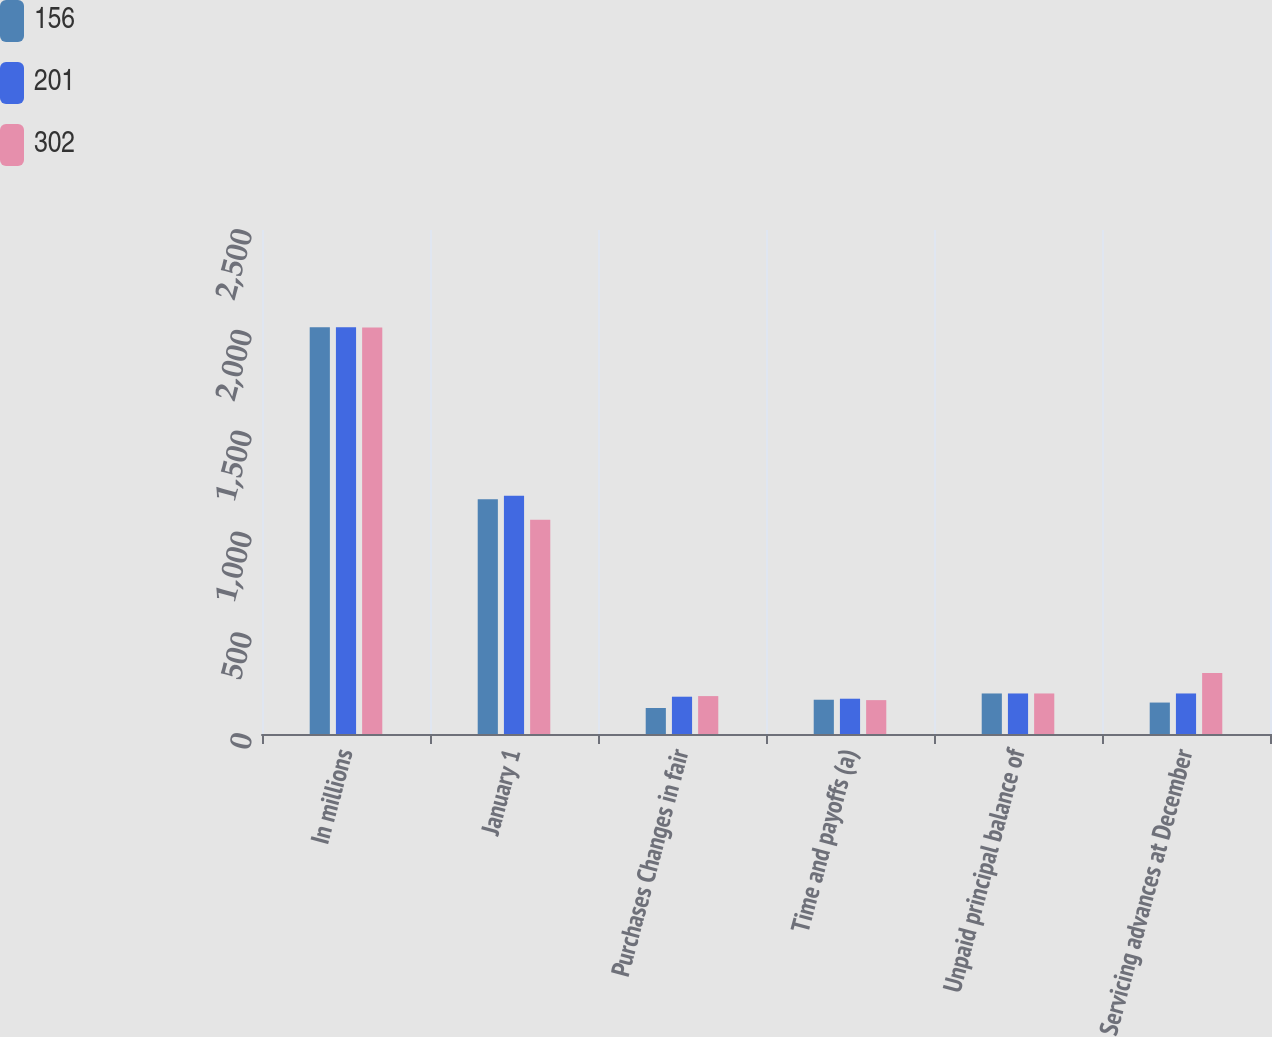Convert chart to OTSL. <chart><loc_0><loc_0><loc_500><loc_500><stacked_bar_chart><ecel><fcel>In millions<fcel>January 1<fcel>Purchases Changes in fair<fcel>Time and payoffs (a)<fcel>Unpaid principal balance of<fcel>Servicing advances at December<nl><fcel>156<fcel>2018<fcel>1164<fcel>129<fcel>170<fcel>201<fcel>156<nl><fcel>201<fcel>2017<fcel>1182<fcel>185<fcel>175<fcel>201<fcel>201<nl><fcel>302<fcel>2016<fcel>1063<fcel>188<fcel>168<fcel>201<fcel>302<nl></chart> 